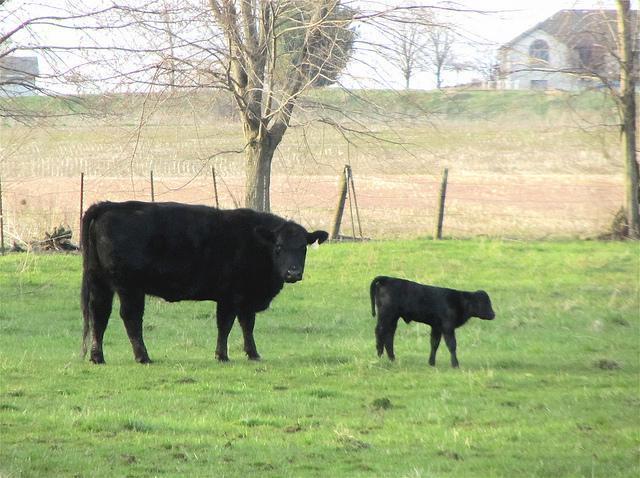How many adult cows are in the picture?
Give a very brief answer. 1. How many cows are on the grass?
Give a very brief answer. 2. How many cows are facing the camera?
Give a very brief answer. 1. How many cows are there?
Give a very brief answer. 2. 